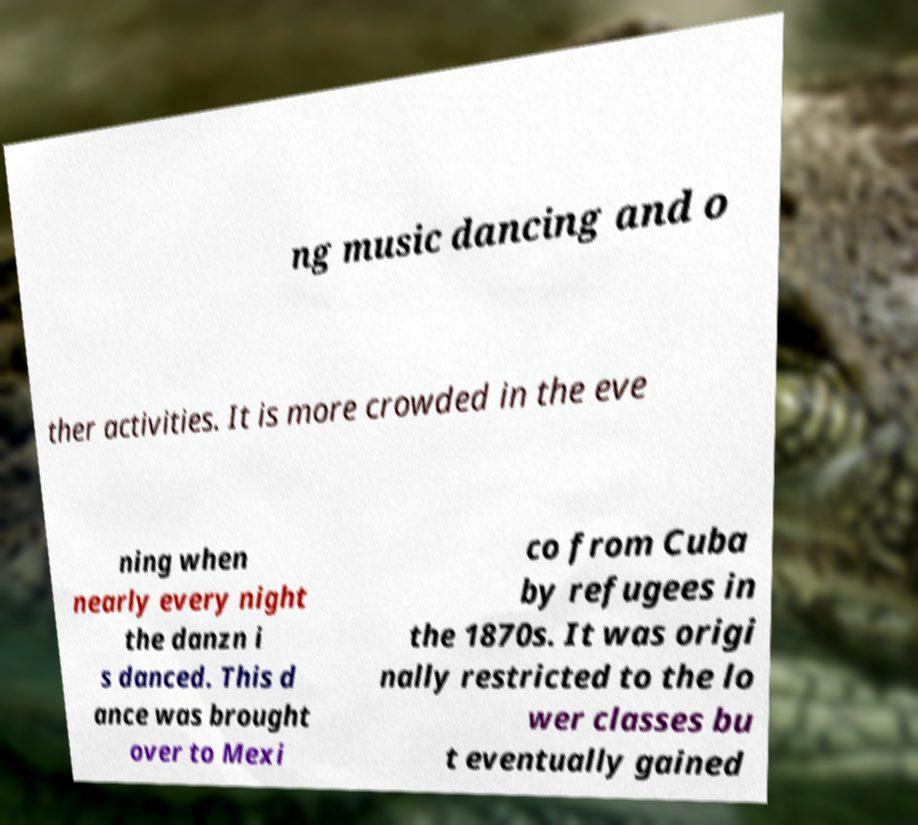What messages or text are displayed in this image? I need them in a readable, typed format. ng music dancing and o ther activities. It is more crowded in the eve ning when nearly every night the danzn i s danced. This d ance was brought over to Mexi co from Cuba by refugees in the 1870s. It was origi nally restricted to the lo wer classes bu t eventually gained 